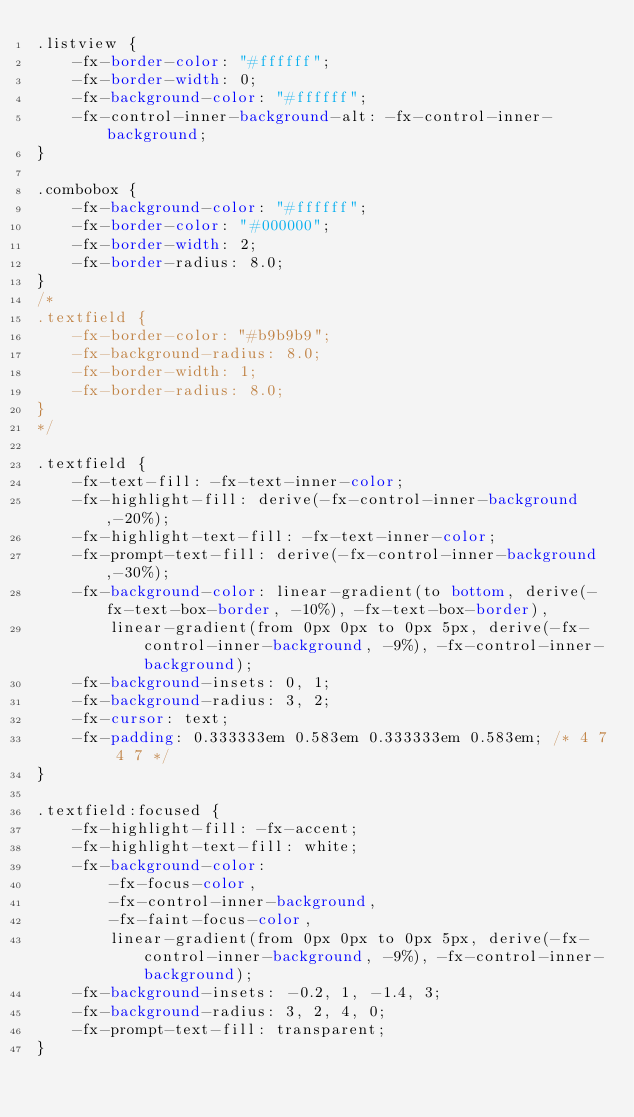Convert code to text. <code><loc_0><loc_0><loc_500><loc_500><_CSS_>.listview {
    -fx-border-color: "#ffffff";
    -fx-border-width: 0;
    -fx-background-color: "#ffffff";
    -fx-control-inner-background-alt: -fx-control-inner-background;
}

.combobox {
    -fx-background-color: "#ffffff";
    -fx-border-color: "#000000";
    -fx-border-width: 2;
    -fx-border-radius: 8.0;
}
/*
.textfield {
    -fx-border-color: "#b9b9b9";
    -fx-background-radius: 8.0;
    -fx-border-width: 1;
    -fx-border-radius: 8.0;
}
*/

.textfield {
    -fx-text-fill: -fx-text-inner-color;
    -fx-highlight-fill: derive(-fx-control-inner-background,-20%);
    -fx-highlight-text-fill: -fx-text-inner-color;
    -fx-prompt-text-fill: derive(-fx-control-inner-background,-30%);
    -fx-background-color: linear-gradient(to bottom, derive(-fx-text-box-border, -10%), -fx-text-box-border),
        linear-gradient(from 0px 0px to 0px 5px, derive(-fx-control-inner-background, -9%), -fx-control-inner-background);
    -fx-background-insets: 0, 1;
    -fx-background-radius: 3, 2;
    -fx-cursor: text;
    -fx-padding: 0.333333em 0.583em 0.333333em 0.583em; /* 4 7 4 7 */
}

.textfield:focused {
    -fx-highlight-fill: -fx-accent;
    -fx-highlight-text-fill: white;
    -fx-background-color:
        -fx-focus-color,
        -fx-control-inner-background,
        -fx-faint-focus-color,
        linear-gradient(from 0px 0px to 0px 5px, derive(-fx-control-inner-background, -9%), -fx-control-inner-background);
    -fx-background-insets: -0.2, 1, -1.4, 3;
    -fx-background-radius: 3, 2, 4, 0;
    -fx-prompt-text-fill: transparent;
}</code> 